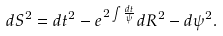Convert formula to latex. <formula><loc_0><loc_0><loc_500><loc_500>d S ^ { 2 } = d t ^ { 2 } - e ^ { 2 \int \frac { d t } { \psi } } d R ^ { 2 } - d \psi ^ { 2 } .</formula> 